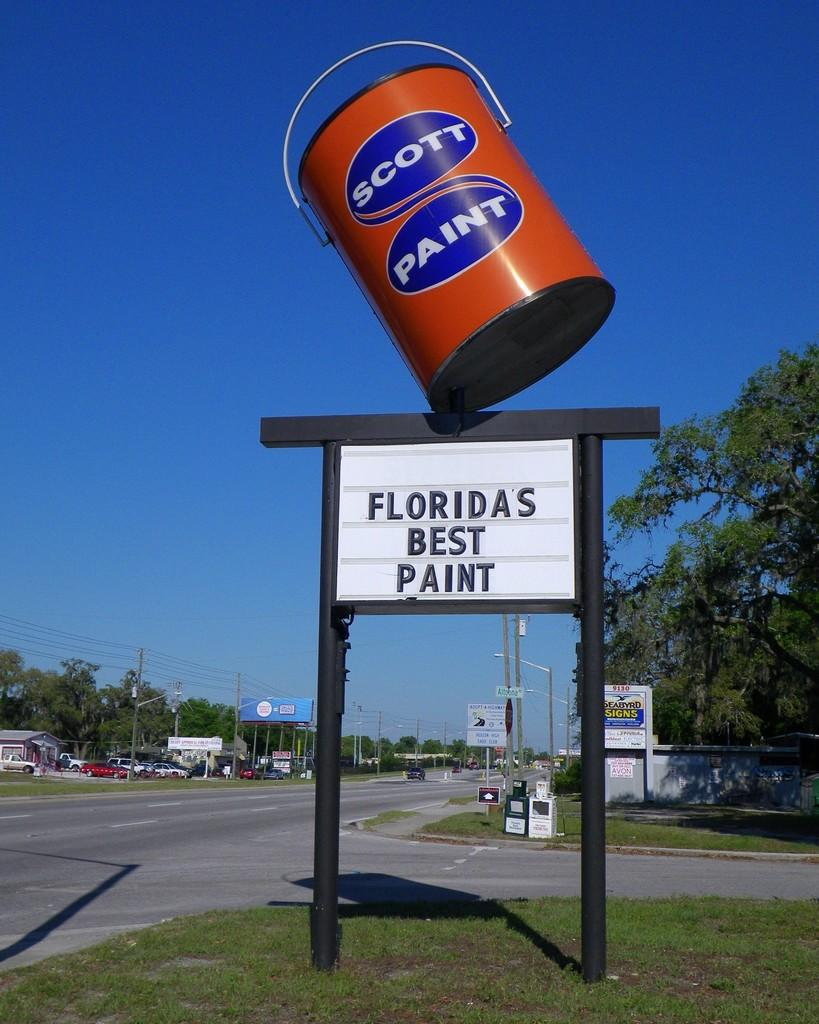<image>
Present a compact description of the photo's key features. a sign for Scott Paint on a big paint can on a road side 